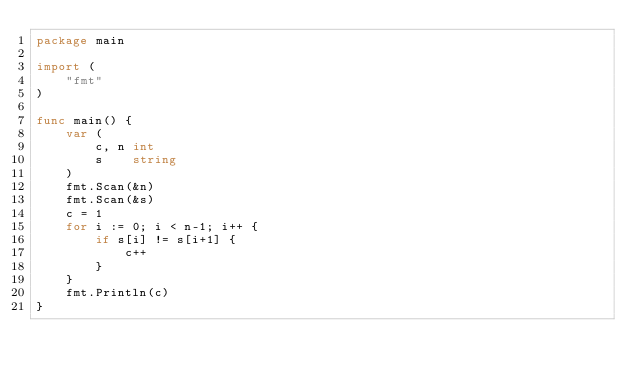<code> <loc_0><loc_0><loc_500><loc_500><_Go_>package main

import (
	"fmt"
)

func main() {
	var (
		c, n int
		s    string
	)
	fmt.Scan(&n)
	fmt.Scan(&s)
	c = 1
	for i := 0; i < n-1; i++ {
		if s[i] != s[i+1] {
			c++
		}
	}
	fmt.Println(c)
}
</code> 